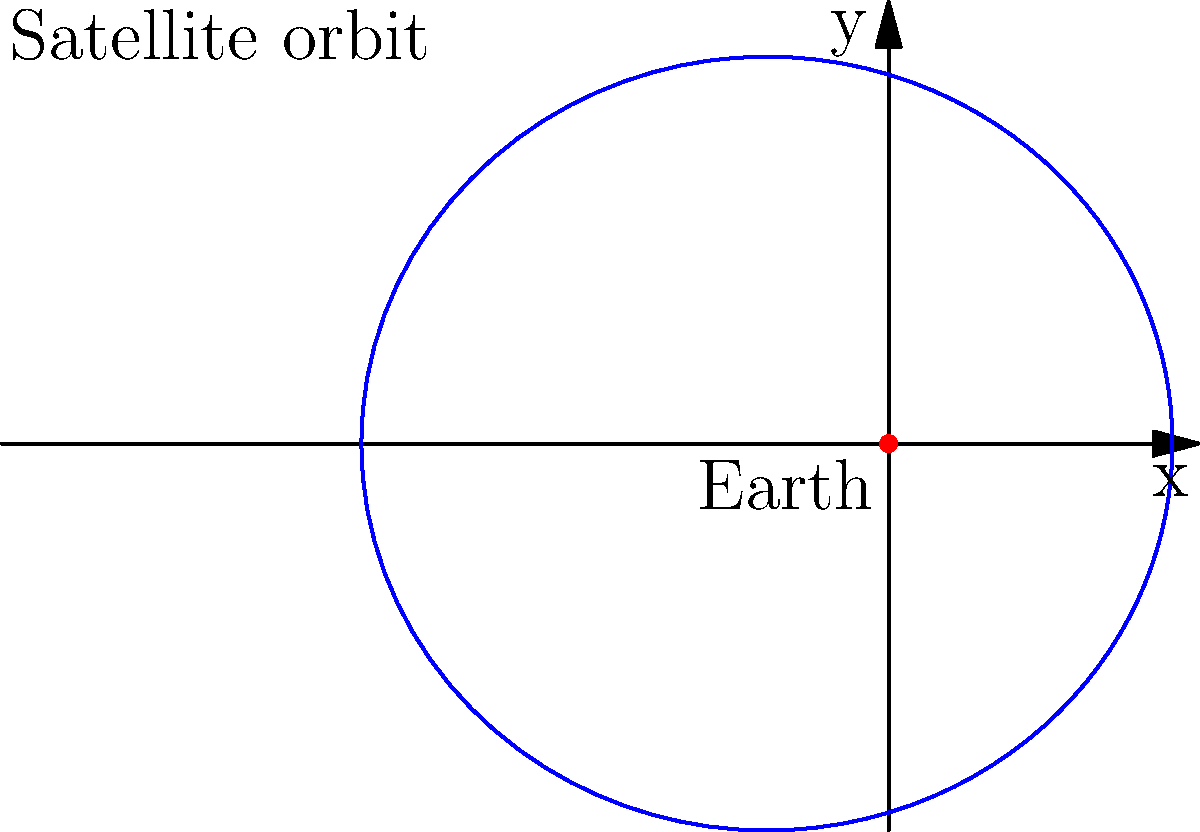A satellite's orbit around Earth is described by the polar equation $r = \frac{1}{1 + 0.3\cos(\theta)}$, where $r$ is in Earth radii. Calculate the satellite's maximum distance from Earth in Earth radii. To find the maximum distance of the satellite from Earth, we need to follow these steps:

1) The maximum distance occurs when $\cos(\theta)$ is at its minimum value, which is -1.

2) Substitute $\cos(\theta) = -1$ into the given equation:

   $r_{max} = \frac{1}{1 + 0.3(-1)} = \frac{1}{1 - 0.3}$

3) Simplify:
   
   $r_{max} = \frac{1}{0.7} = \frac{10}{7}$

4) Convert the fraction to a decimal:

   $r_{max} \approx 1.4286$ Earth radii

Therefore, the maximum distance of the satellite from Earth is approximately 1.4286 Earth radii.
Answer: $\frac{10}{7}$ Earth radii 